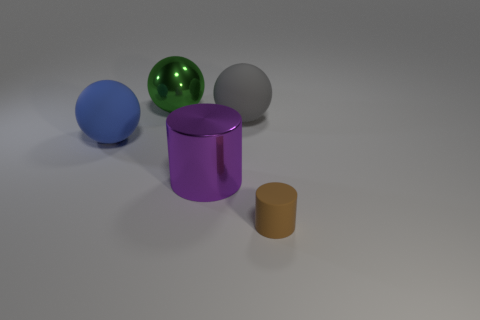Are there any brown rubber things that have the same size as the metallic ball?
Make the answer very short. No. Does the blue object have the same material as the large green ball?
Ensure brevity in your answer.  No. How many objects are shiny spheres or tiny matte cylinders?
Provide a short and direct response. 2. What size is the purple metallic object?
Ensure brevity in your answer.  Large. Is the number of big purple cylinders less than the number of big matte things?
Provide a succinct answer. Yes. Is the color of the rubber sphere left of the large green ball the same as the rubber cylinder?
Provide a short and direct response. No. The large matte object on the left side of the purple cylinder has what shape?
Make the answer very short. Sphere. Are there any large purple metallic things that are to the right of the big rubber ball that is in front of the gray ball?
Ensure brevity in your answer.  Yes. What number of large green things are made of the same material as the big cylinder?
Offer a very short reply. 1. What is the size of the matte sphere behind the object on the left side of the metal object behind the large gray rubber sphere?
Your response must be concise. Large. 